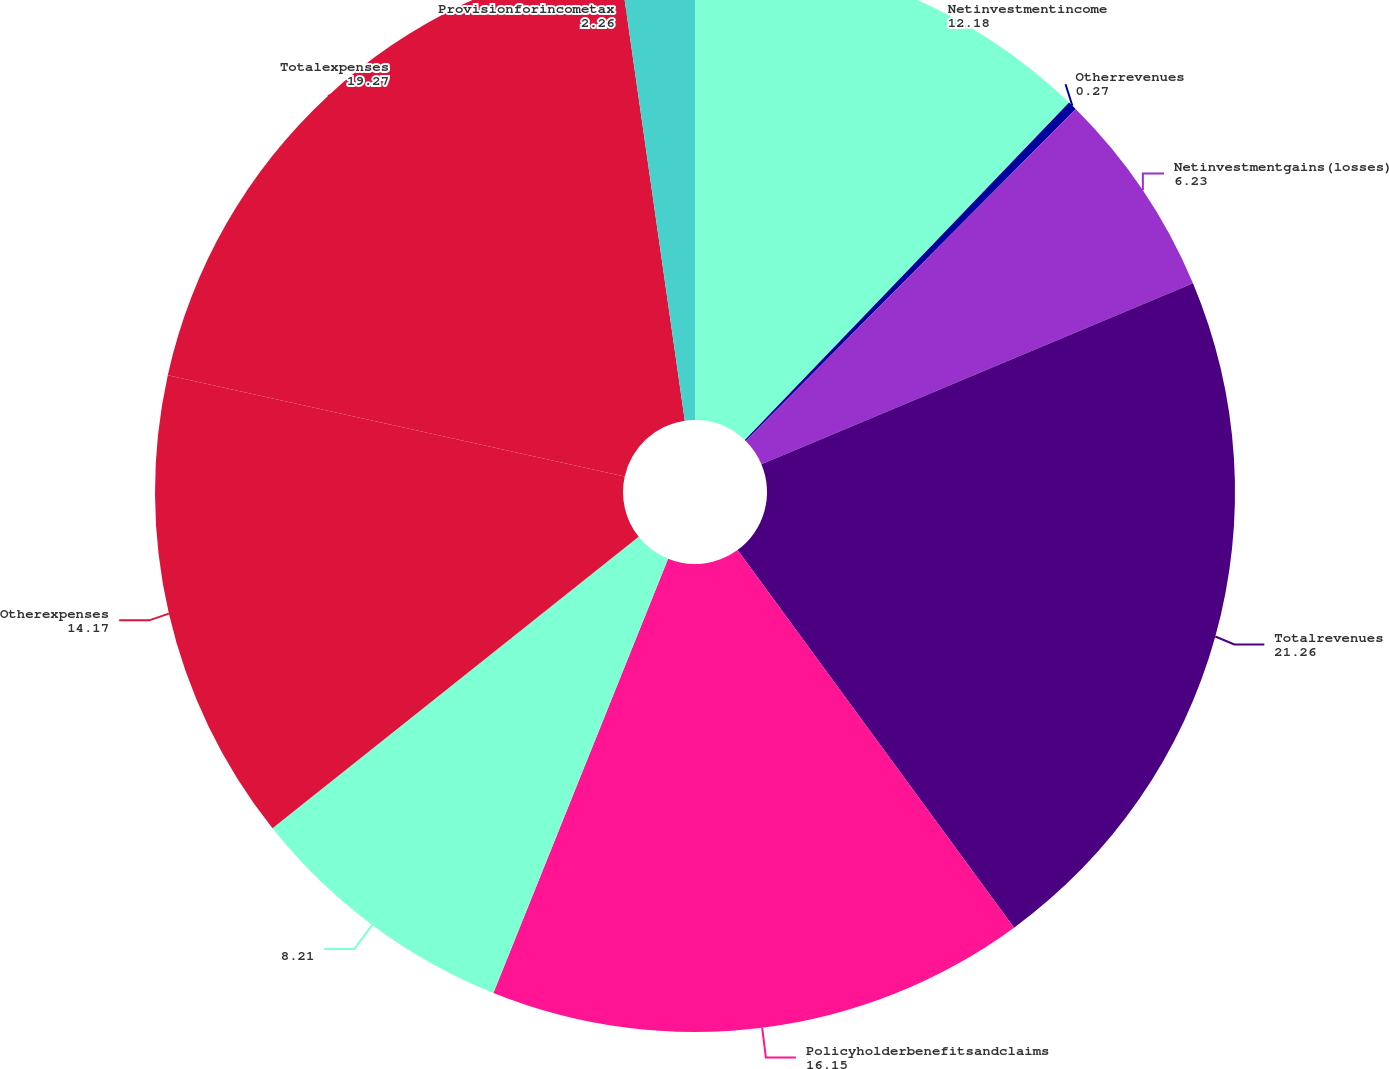Convert chart to OTSL. <chart><loc_0><loc_0><loc_500><loc_500><pie_chart><fcel>Netinvestmentincome<fcel>Otherrevenues<fcel>Netinvestmentgains(losses)<fcel>Totalrevenues<fcel>Policyholderbenefitsandclaims<fcel>Unnamed: 5<fcel>Otherexpenses<fcel>Totalexpenses<fcel>Provisionforincometax<nl><fcel>12.18%<fcel>0.27%<fcel>6.23%<fcel>21.26%<fcel>16.15%<fcel>8.21%<fcel>14.17%<fcel>19.27%<fcel>2.26%<nl></chart> 